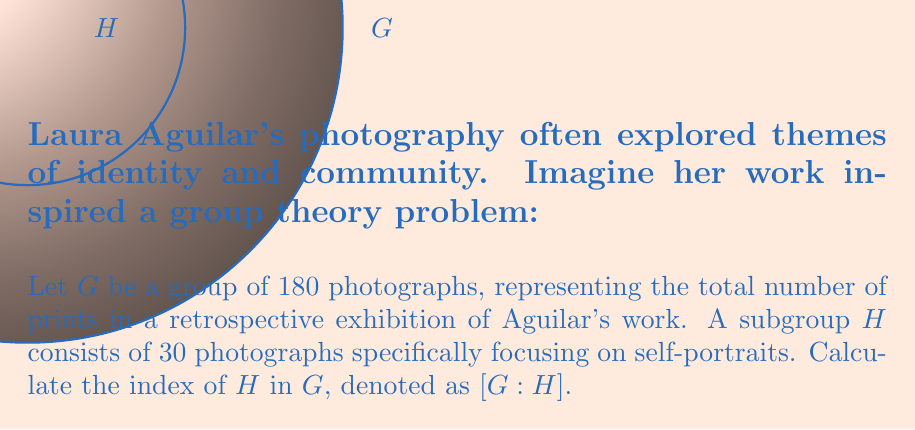Can you answer this question? To calculate the index of a subgroup, we use the formula:

$[G:H] = \frac{|G|}{|H|}$

Where:
- $|G|$ is the order (number of elements) of the larger group $G$
- $|H|$ is the order of the subgroup $H$

Given:
- $|G| = 180$ (total number of photographs)
- $|H| = 30$ (number of self-portraits)

Substituting these values into the formula:

$[G:H] = \frac{180}{30}$

Simplifying:

$[G:H] = 6$

This means that there are 6 distinct left (or right) cosets of $H$ in $G$, or equivalently, that $G$ can be partitioned into 6 subsets, each with 30 elements.
Answer: $[G:H] = 6$ 